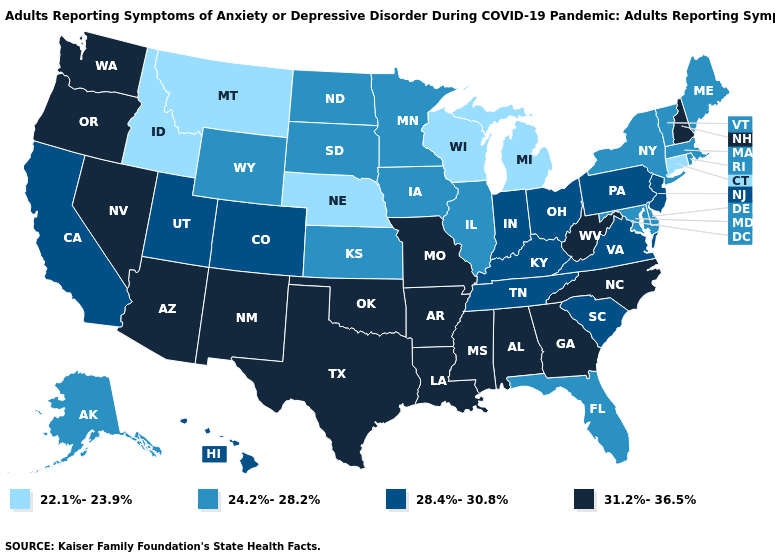What is the value of Massachusetts?
Quick response, please. 24.2%-28.2%. What is the value of New York?
Quick response, please. 24.2%-28.2%. Name the states that have a value in the range 28.4%-30.8%?
Quick response, please. California, Colorado, Hawaii, Indiana, Kentucky, New Jersey, Ohio, Pennsylvania, South Carolina, Tennessee, Utah, Virginia. Name the states that have a value in the range 22.1%-23.9%?
Give a very brief answer. Connecticut, Idaho, Michigan, Montana, Nebraska, Wisconsin. Name the states that have a value in the range 22.1%-23.9%?
Answer briefly. Connecticut, Idaho, Michigan, Montana, Nebraska, Wisconsin. What is the highest value in states that border Alabama?
Keep it brief. 31.2%-36.5%. What is the lowest value in the MidWest?
Give a very brief answer. 22.1%-23.9%. What is the highest value in states that border West Virginia?
Concise answer only. 28.4%-30.8%. Is the legend a continuous bar?
Keep it brief. No. Does Michigan have the lowest value in the USA?
Give a very brief answer. Yes. Name the states that have a value in the range 22.1%-23.9%?
Quick response, please. Connecticut, Idaho, Michigan, Montana, Nebraska, Wisconsin. What is the lowest value in the USA?
Answer briefly. 22.1%-23.9%. Name the states that have a value in the range 22.1%-23.9%?
Keep it brief. Connecticut, Idaho, Michigan, Montana, Nebraska, Wisconsin. Which states have the highest value in the USA?
Answer briefly. Alabama, Arizona, Arkansas, Georgia, Louisiana, Mississippi, Missouri, Nevada, New Hampshire, New Mexico, North Carolina, Oklahoma, Oregon, Texas, Washington, West Virginia. Name the states that have a value in the range 24.2%-28.2%?
Keep it brief. Alaska, Delaware, Florida, Illinois, Iowa, Kansas, Maine, Maryland, Massachusetts, Minnesota, New York, North Dakota, Rhode Island, South Dakota, Vermont, Wyoming. 